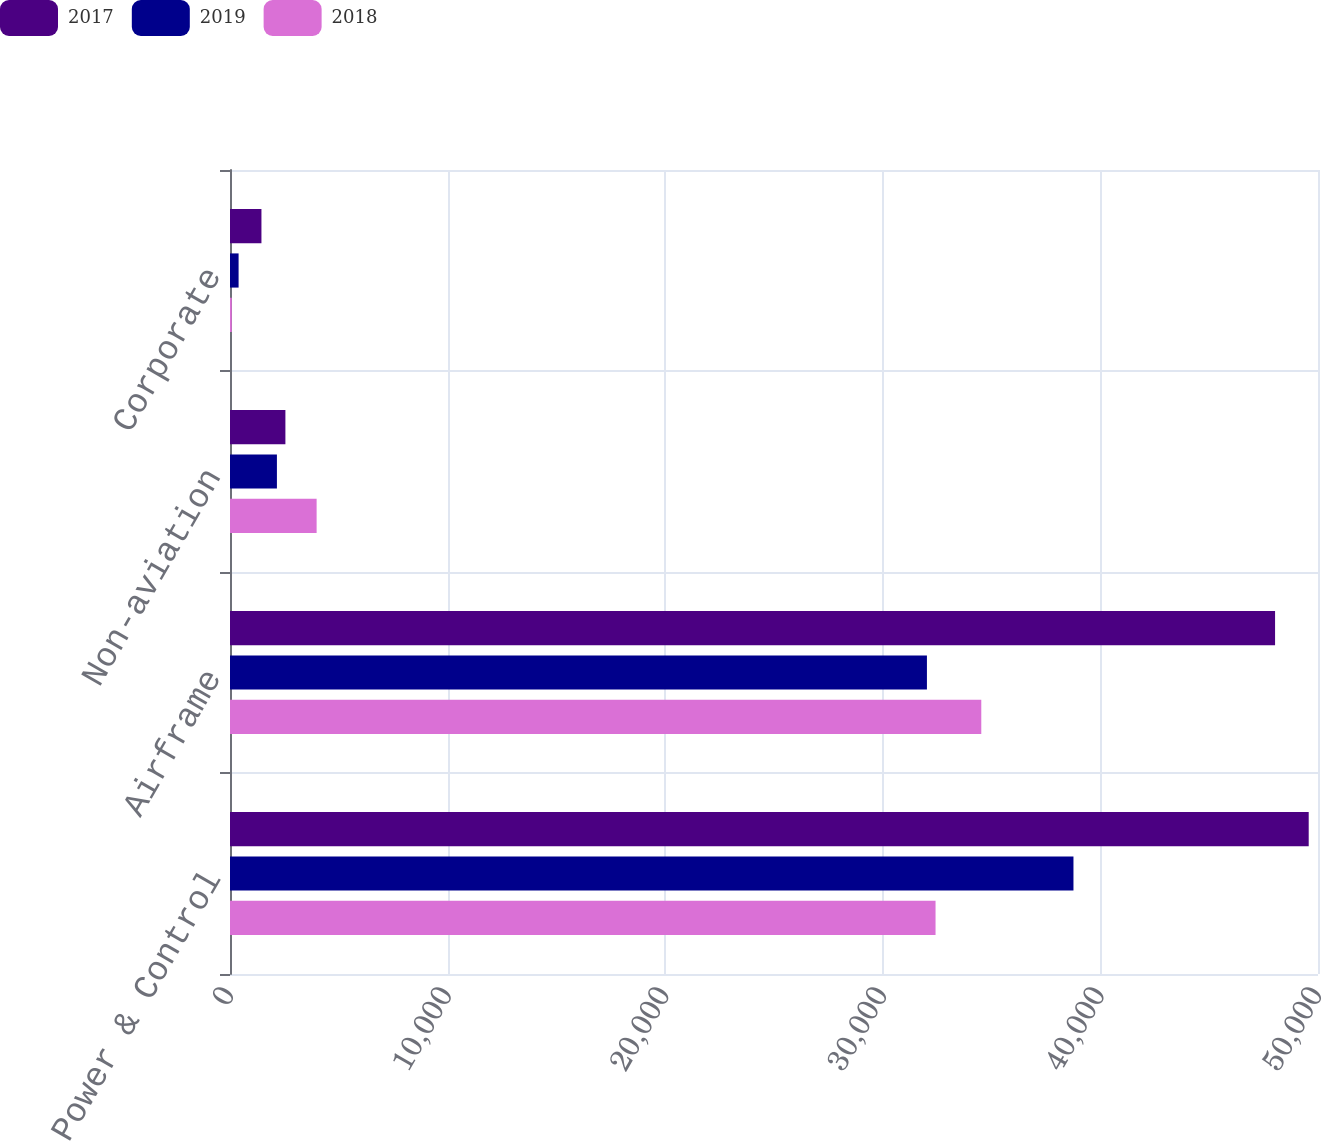Convert chart to OTSL. <chart><loc_0><loc_0><loc_500><loc_500><stacked_bar_chart><ecel><fcel>Power & Control<fcel>Airframe<fcel>Non-aviation<fcel>Corporate<nl><fcel>2017<fcel>49573<fcel>48027<fcel>2546<fcel>1445<nl><fcel>2019<fcel>38762<fcel>32028<fcel>2156<fcel>395<nl><fcel>2018<fcel>32424<fcel>34526<fcel>3981<fcel>82<nl></chart> 